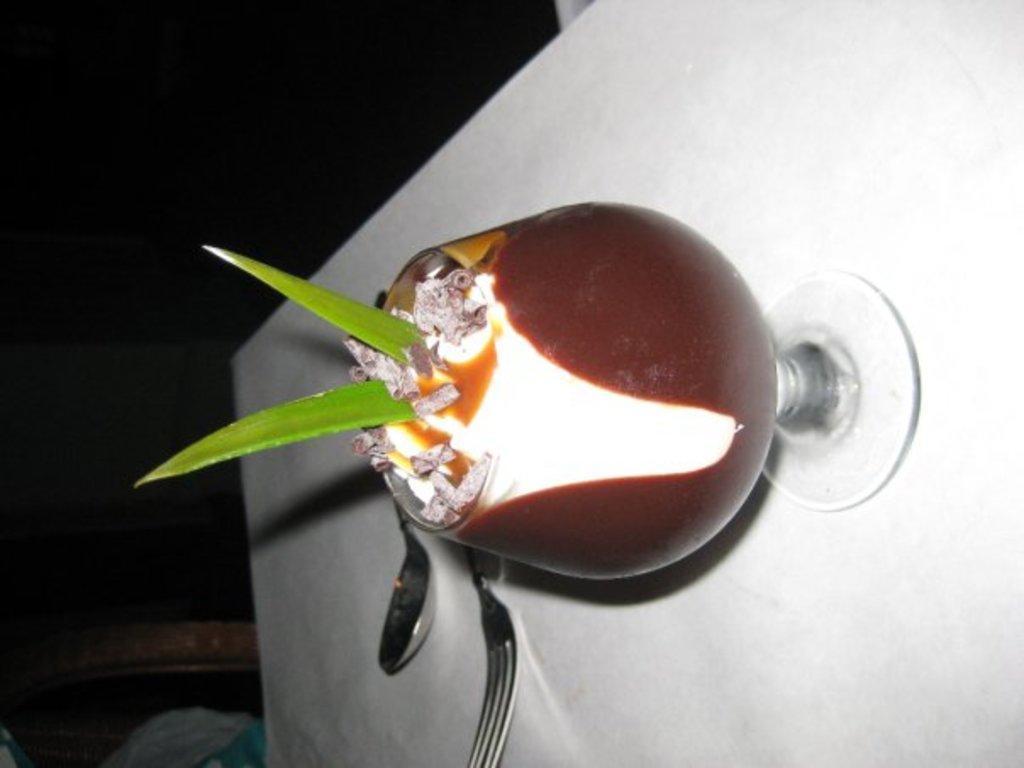Can you describe this image briefly? In this picture there is a glass of drink which has two aloe vera strips in it and there is a spoon and fork beside it. 